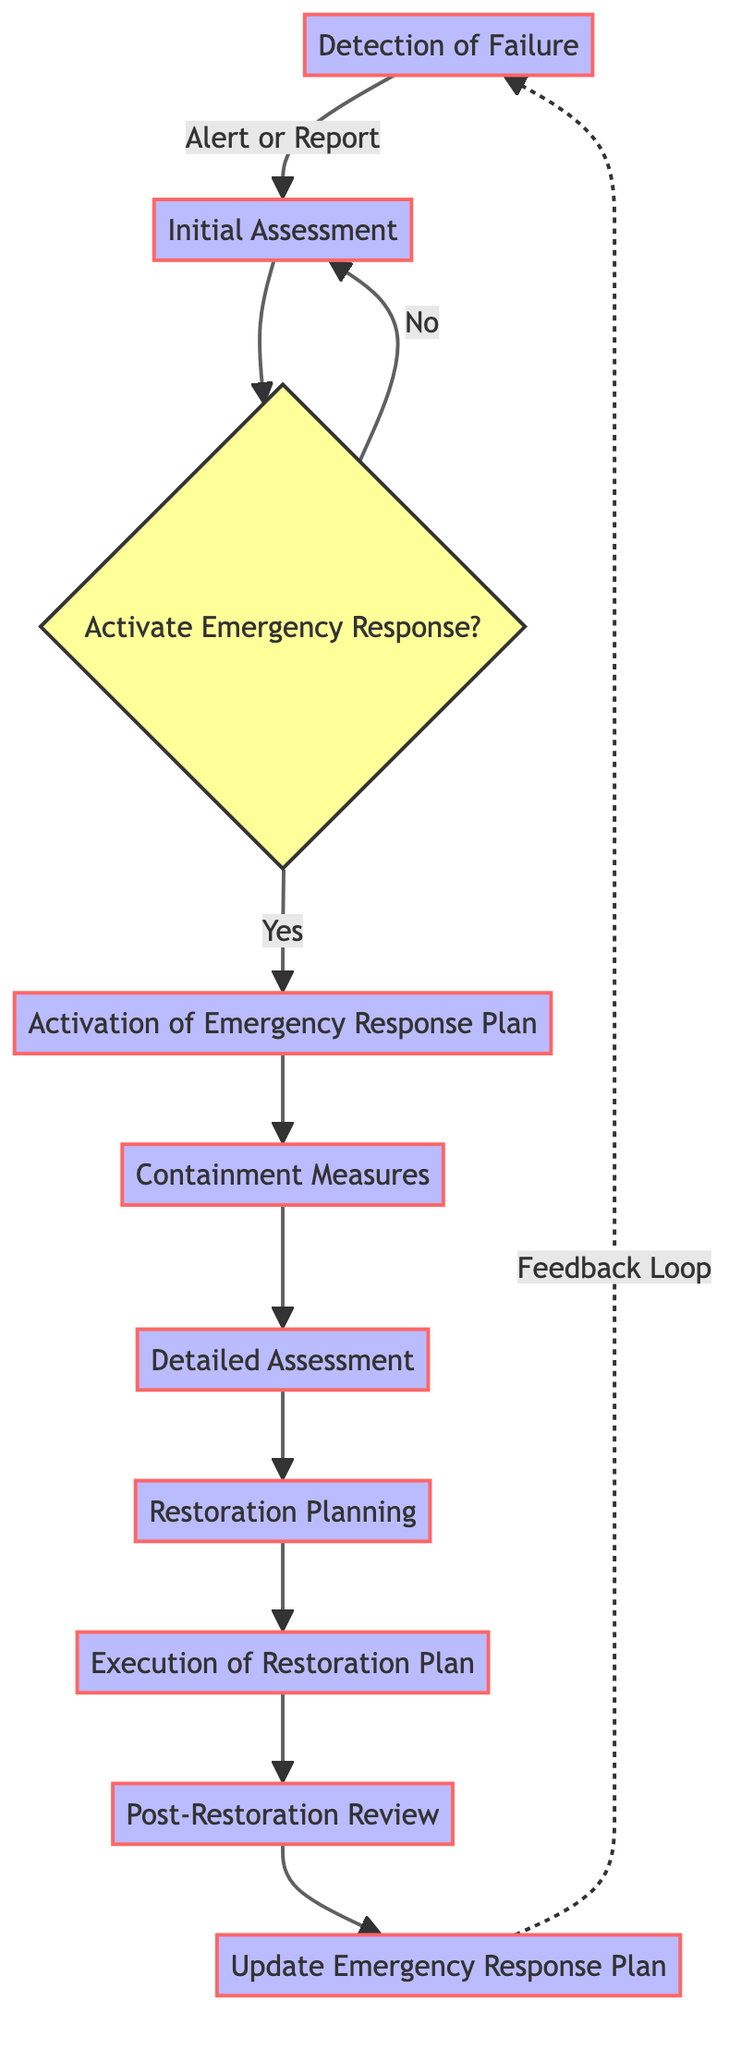What is the first step in the workflow? The first step in the workflow as presented in the diagram is "Detection of Failure," indicating that identifying the infrastructure failure is the starting point.
Answer: Detection of Failure How many total nodes are in the diagram? By counting the different processes listed in the diagram, along with the decision node, there are a total of ten nodes representing various stages in the emergency response workflow.
Answer: 10 What action follows the "Initial Assessment"? The "Initial Assessment" leads to a decision node labeled "Activate Emergency Response?" which determines whether to proceed to the "Activation of Emergency Response Plan."
Answer: Activate Emergency Response? In which step do detailed assessments take place? The detailed assessments happen at the "Detailed Assessment" step, where the evaluation of damage and implications is conducted comprehensively.
Answer: Detailed Assessment What measures are implemented after the "Activation of Emergency Response Plan"? After the "Activation of Emergency Response Plan," "Containment Measures" are implemented to prevent further damage or risk following the failure.
Answer: Containment Measures If the emergency response plan is not activated, where does the process go? If the response plan is not activated, the process loops back to the "Initial Assessment," allowing for reevaluation of the situation.
Answer: Initial Assessment Which step occurs right before the "Post-Restoration Review"? The step that occurs just prior to the "Post-Restoration Review" is the "Execution of Restoration Plan," where the repair and restoration activities are carried out.
Answer: Execution of Restoration Plan What is done after the "Post-Restoration Review"? Following the "Post-Restoration Review," the next step is to "Update Emergency Response Plan," incorporating lessons learned and updating protocols accordingly.
Answer: Update Emergency Response Plan Which node represents a decision point in the workflow? The node labeled "Activate Emergency Response?" serves as the decision point in the workflow, directing the process based on whether to activate the emergency response.
Answer: Activate Emergency Response? 